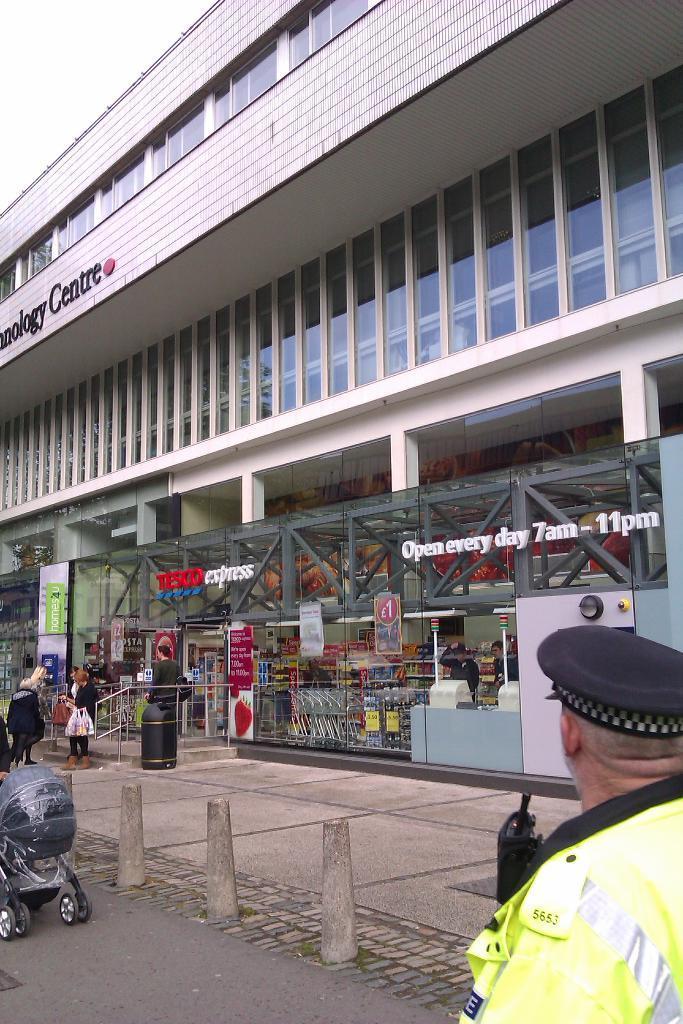Could you give a brief overview of what you see in this image? In the image we can see there are people standing on the road. Beside there is a building and it is a shopping mall. 